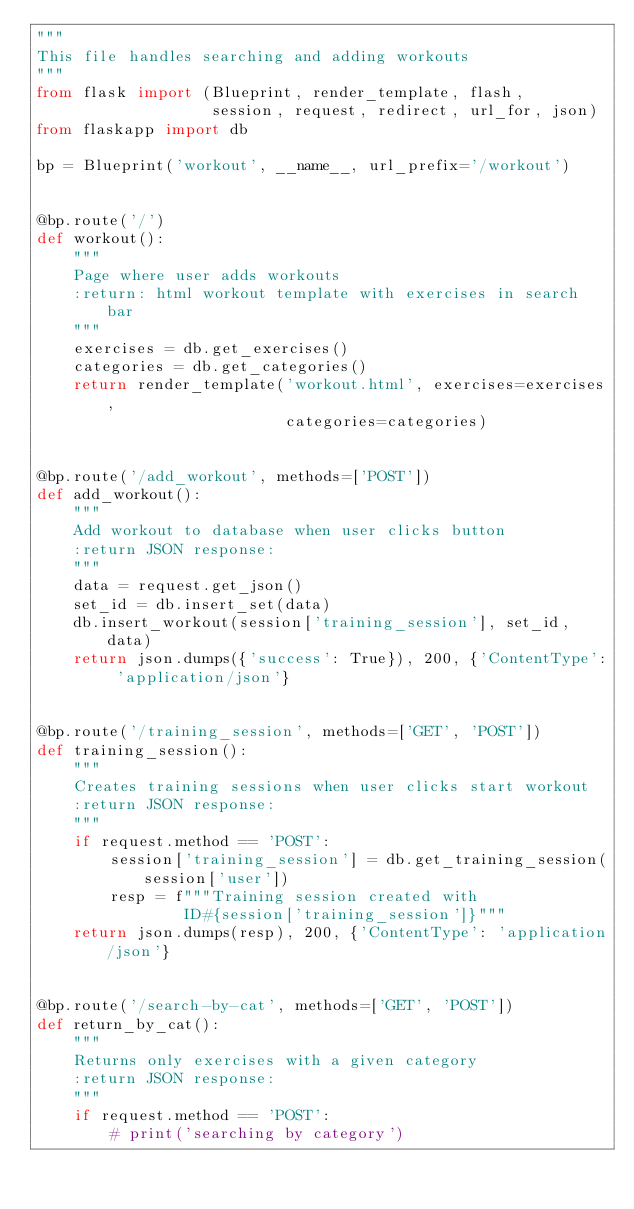<code> <loc_0><loc_0><loc_500><loc_500><_Python_>"""
This file handles searching and adding workouts
"""
from flask import (Blueprint, render_template, flash,
                   session, request, redirect, url_for, json)
from flaskapp import db

bp = Blueprint('workout', __name__, url_prefix='/workout')


@bp.route('/')
def workout():
    """
    Page where user adds workouts
    :return: html workout template with exercises in search bar
    """
    exercises = db.get_exercises()
    categories = db.get_categories()
    return render_template('workout.html', exercises=exercises,
                           categories=categories)


@bp.route('/add_workout', methods=['POST'])
def add_workout():
    """
    Add workout to database when user clicks button
    :return JSON response:
    """
    data = request.get_json()
    set_id = db.insert_set(data)
    db.insert_workout(session['training_session'], set_id, data)
    return json.dumps({'success': True}), 200, {'ContentType': 'application/json'}


@bp.route('/training_session', methods=['GET', 'POST'])
def training_session():
    """
    Creates training sessions when user clicks start workout
    :return JSON response:
    """
    if request.method == 'POST':
        session['training_session'] = db.get_training_session(session['user'])
        resp = f"""Training session created with 
                ID#{session['training_session']}"""
    return json.dumps(resp), 200, {'ContentType': 'application/json'}


@bp.route('/search-by-cat', methods=['GET', 'POST'])
def return_by_cat():
    """
    Returns only exercises with a given category
    :return JSON response:
    """
    if request.method == 'POST':
        # print('searching by category')</code> 